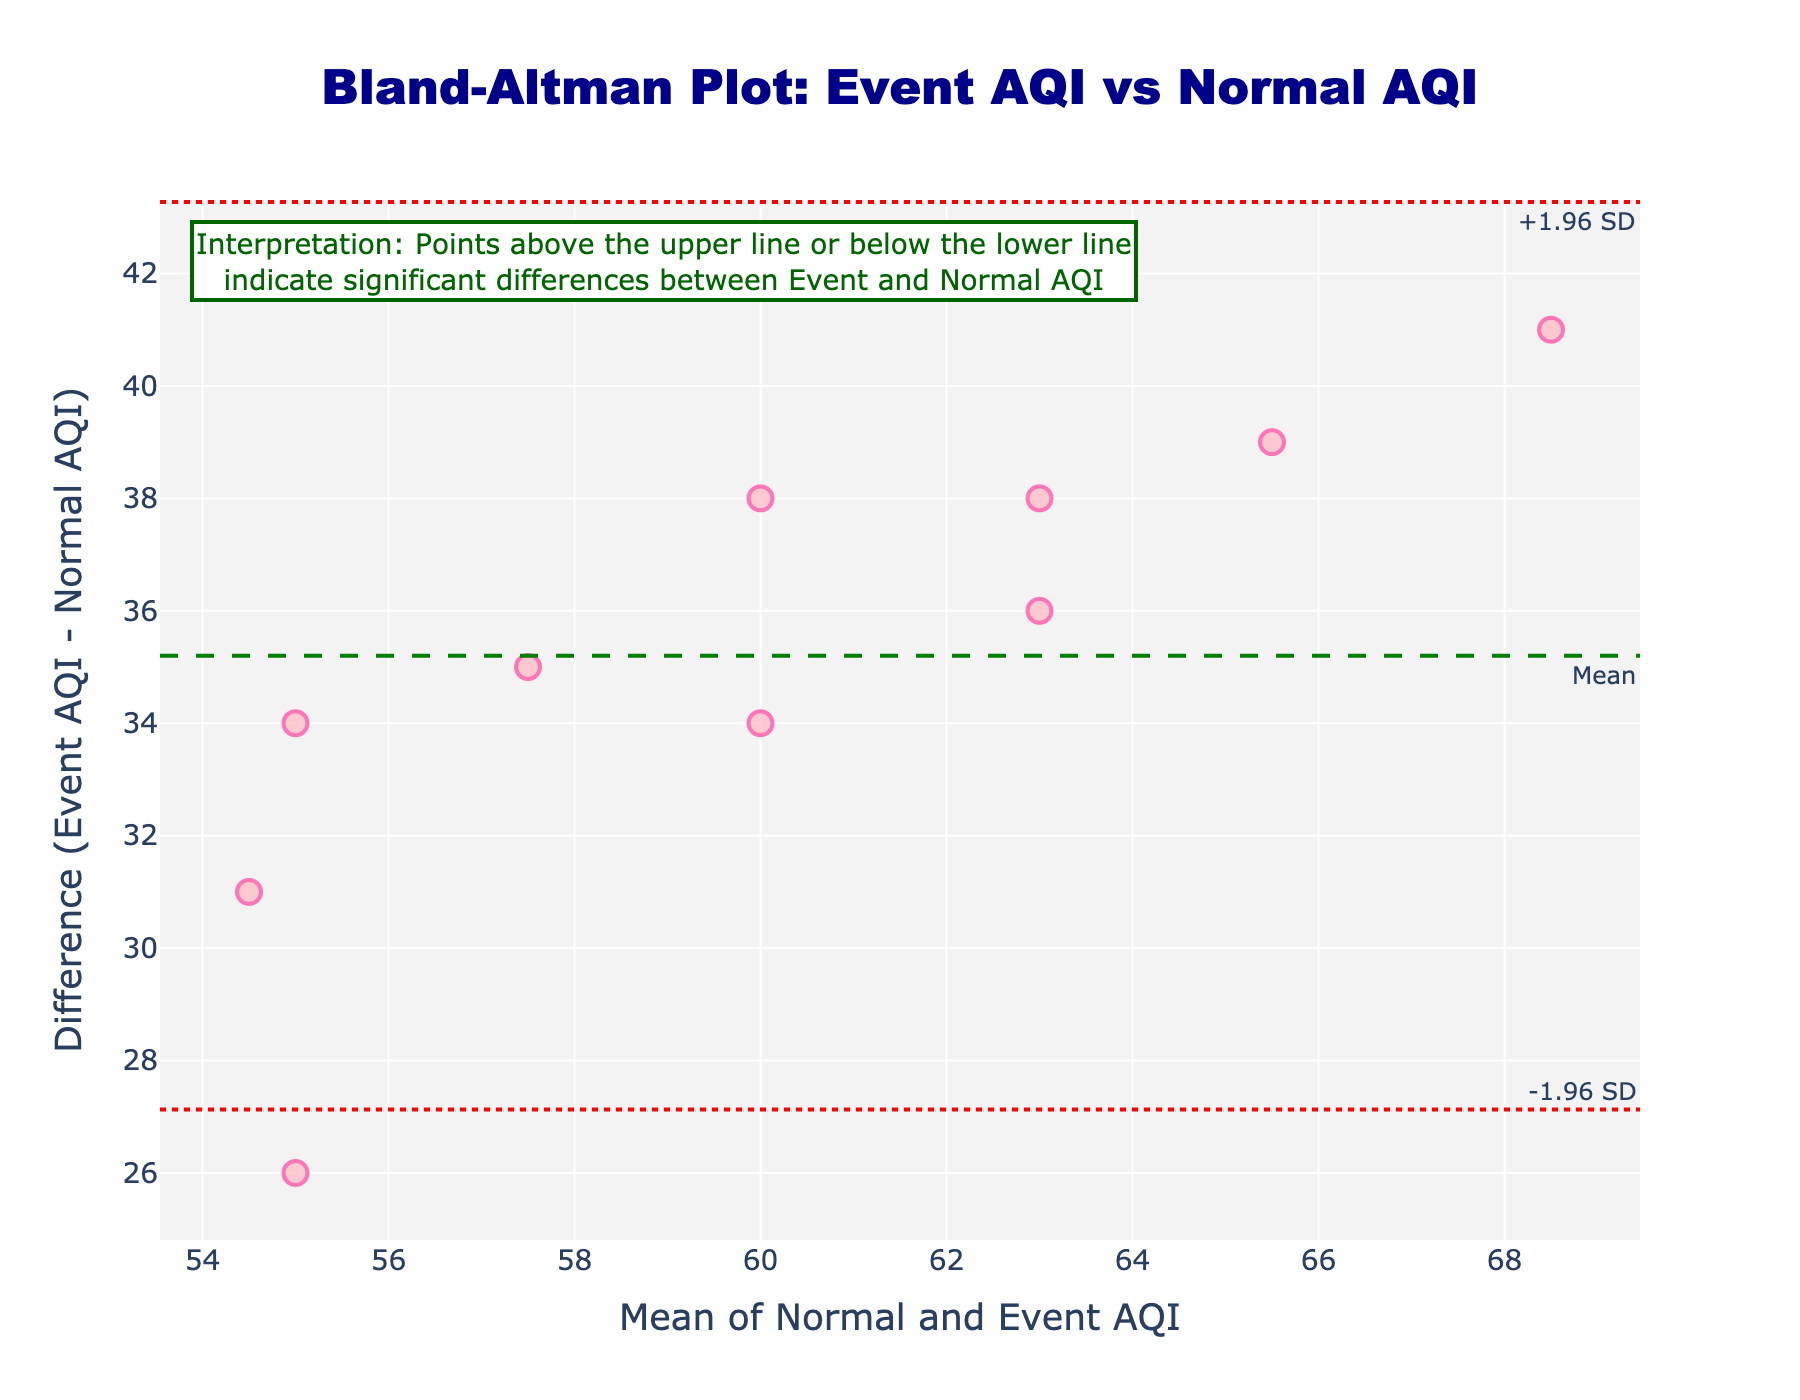How many data points are shown in the plot? Count the number of data points (markers) on the scatter plot.
Answer: 10 What is the title of the plot? Look at the title text positioned at the top center of the figure.
Answer: Bland-Altman Plot: Event AQI vs Normal AQI What do the dashed green and dotted red lines represent? Examine the annotation texts near the lines: the green dashed line is labeled "Mean", and the red dotted lines are labeled "+1.96 SD" and "-1.96 SD".
Answer: Mean and limits of agreement What's the difference between the normal and event AQI on July 4th? Locate the marker corresponding to July 4th, and read the difference in the y-axis values.
Answer: 41 What is the average AQI on August 5th? Refer to the x-axis value associated with the marker for August 5th.
Answer: 65.5 Is the point corresponding to July 22nd above or below the mean difference line? Look at the position of the marker for July 22nd relative to the green dashed line.
Answer: Above Which date has the largest difference in AQI between normal days and event days? Identify the marker with the greatest vertical distance from the mean difference line. Read the exact date corresponding to this marker.
Answer: July 4th What's the lower limit of agreement in this plot? Look at the y-value of the lower red dotted line annotated "-1.96 SD".
Answer: Lower LoA value (exact value can be found visually on plot) How many points lie outside the limits of agreement? Count the number of points that are either above the upper red dotted line or below the lower red dotted line.
Answer: Number of points outside limits (exact count) 